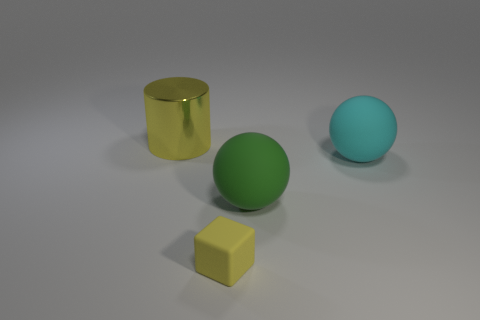There is a yellow rubber thing on the left side of the big cyan matte sphere; what is its size? The yellow object appears to be a small cube, significantly smaller in size when compared with the cyan sphere next to it. Based on relative proportions, the cube might only be a fraction of the sphere's diameter. 